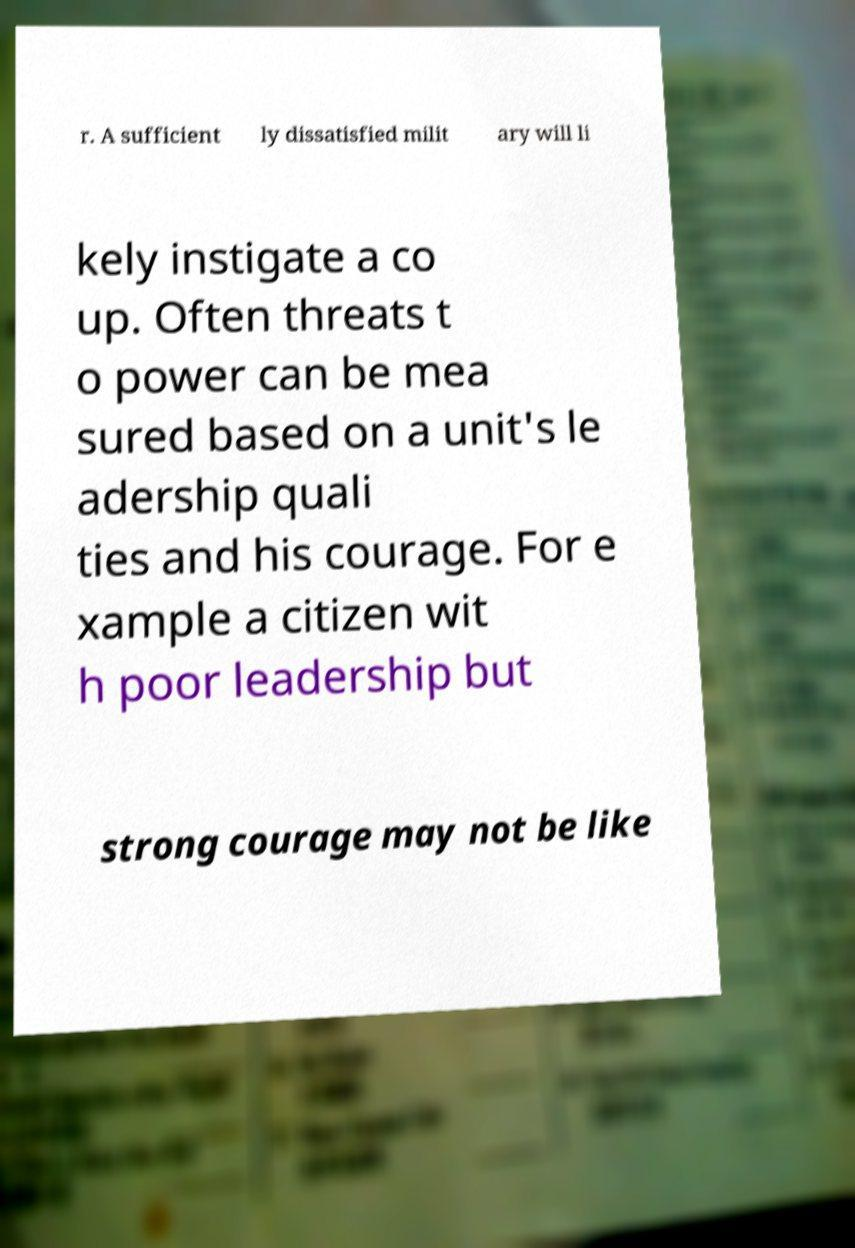Please identify and transcribe the text found in this image. r. A sufficient ly dissatisfied milit ary will li kely instigate a co up. Often threats t o power can be mea sured based on a unit's le adership quali ties and his courage. For e xample a citizen wit h poor leadership but strong courage may not be like 